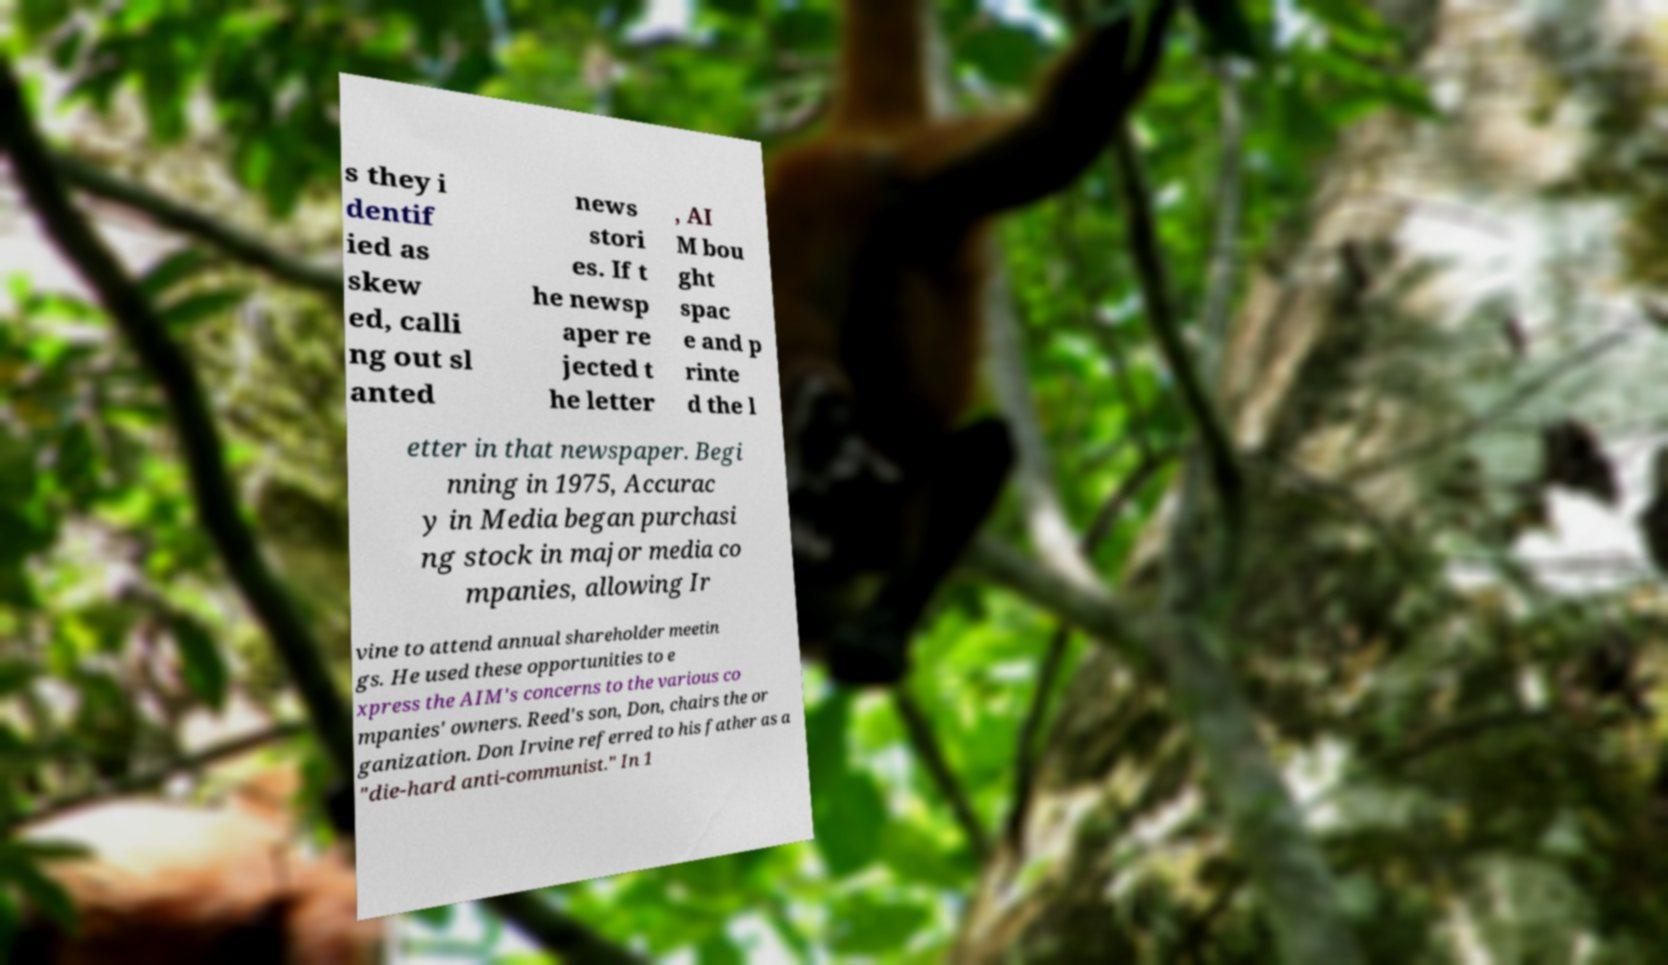I need the written content from this picture converted into text. Can you do that? s they i dentif ied as skew ed, calli ng out sl anted news stori es. If t he newsp aper re jected t he letter , AI M bou ght spac e and p rinte d the l etter in that newspaper. Begi nning in 1975, Accurac y in Media began purchasi ng stock in major media co mpanies, allowing Ir vine to attend annual shareholder meetin gs. He used these opportunities to e xpress the AIM's concerns to the various co mpanies' owners. Reed's son, Don, chairs the or ganization. Don Irvine referred to his father as a "die-hard anti-communist." In 1 